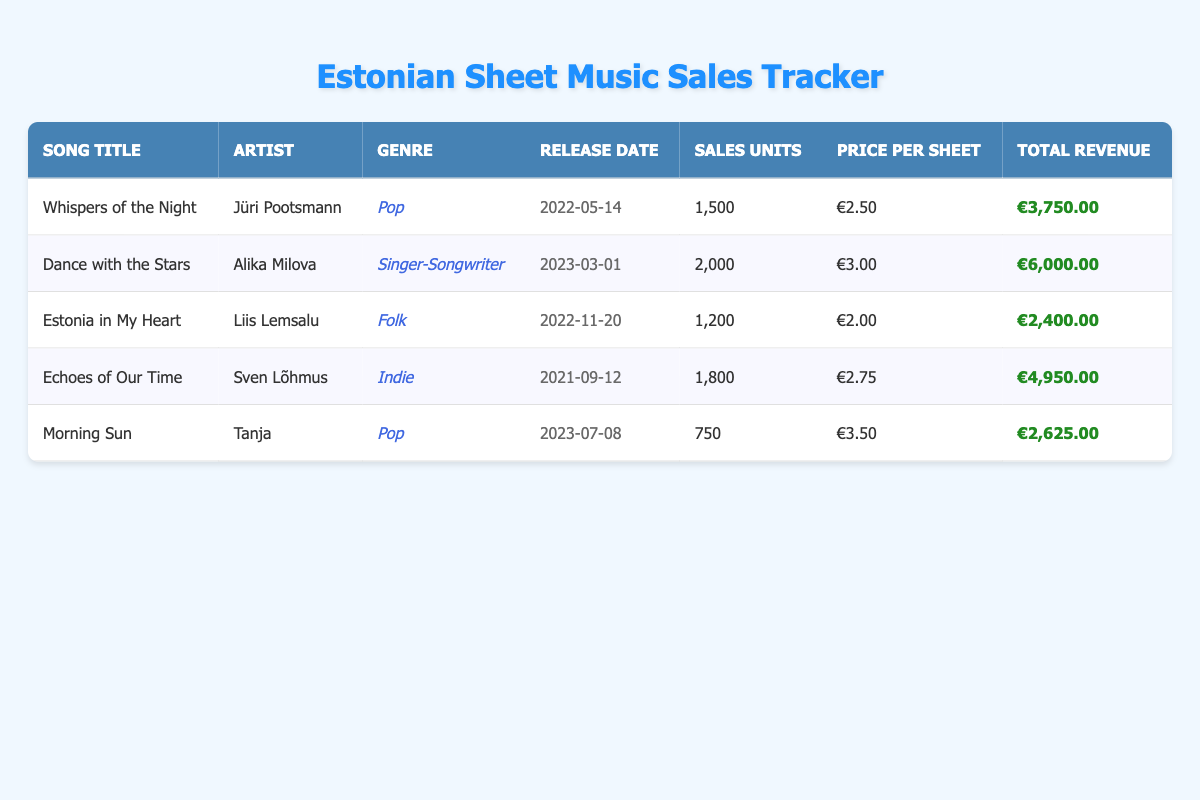What is the total revenue generated by "Dance with the Stars"? The total revenue for "Dance with the Stars" is stated directly in the table. By looking in the total revenue column corresponding to the row of "Dance with the Stars," we find it listed as €6,000.00.
Answer: €6,000.00 Which song has the highest sales units? By comparing the sales units column, "Dance with the Stars" has 2,000 units sold, which is higher than the other songs listed. Thus, it has the highest sales units.
Answer: "Dance with the Stars" Is the price per sheet for "Morning Sun" higher than €3.00? The price per sheet for "Morning Sun" is listed as €3.50 in the price per sheet column. Since €3.50 is greater than €3.00, the statement is true.
Answer: Yes What is the average price per sheet for all songs? To find the average price per sheet, first sum the prices: €2.50 + €3.00 + €2.00 + €2.75 + €3.50 = €13.75. Then divide by the number of songs, which is 5: €13.75 / 5 = €2.75.
Answer: €2.75 How much total revenue do the Pop genre songs generate? The two Pop songs are "Whispers of the Night" with €3,750.00 and "Morning Sun" with €2,625.00. Adding them together gives €3,750.00 + €2,625.00 = €6,375.00 in total revenue from the Pop genre songs.
Answer: €6,375.00 What is the release date of "Estonia in My Heart"? The release date is provided in the corresponding row for "Estonia in My Heart." It is listed in the release date column as 2022-11-20.
Answer: 2022-11-20 Is "Echoes of Our Time" classified as a Folk song? The genre specified for "Echoes of Our Time" is Indie, which means it is not classified as Folk. Therefore, the statement is false.
Answer: No Which song has the lowest total revenue? By examining the total revenue column, "Estonia in My Heart" has the lowest total revenue of €2,400.00, compared to the other songs listed.
Answer: "Estonia in My Heart" What is the difference in sales units between "Dance with the Stars" and "Morning Sun"? The sales units for "Dance with the Stars" is 2,000 and for "Morning Sun" is 750. The difference is calculated as 2,000 - 750 = 1,250 units.
Answer: 1,250 units 